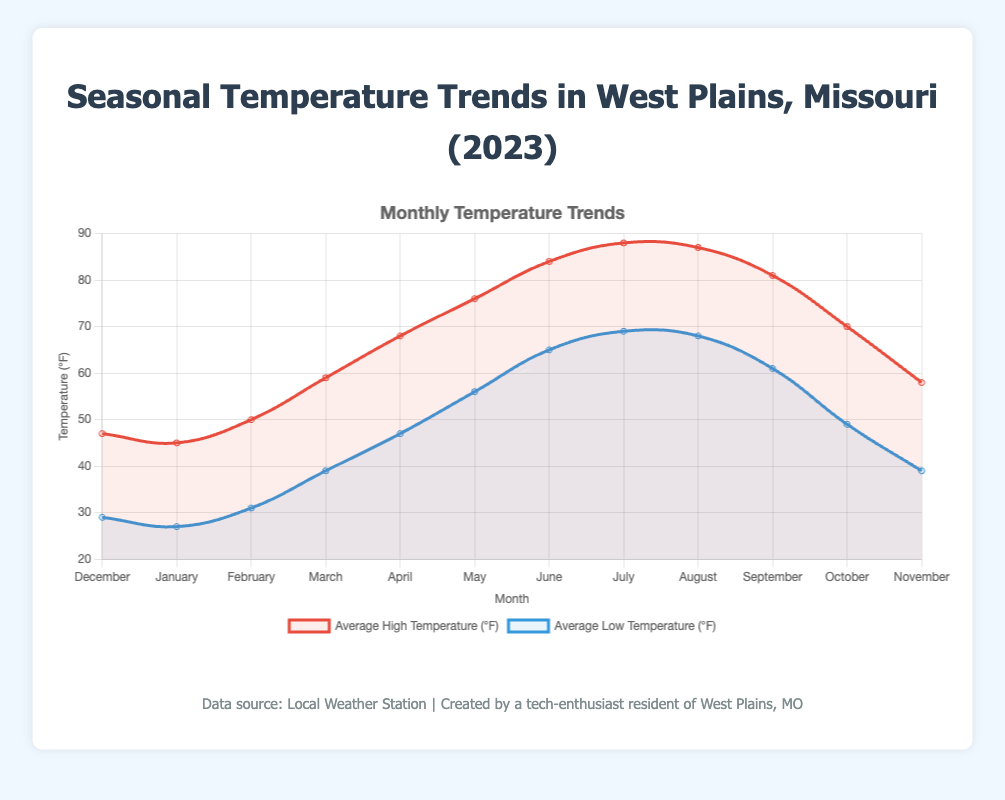When does West Plains, Missouri experience the highest average low temperature? The highest average low temperature can be identified by looking for the highest point on the blue line, which represents the average low temperatures. This occurs in July, with an average low temperature of 69°F.
Answer: July Which month has the greatest difference between the average high and low temperatures? To find this, calculate the difference between the high and low temperatures for each month and identify the largest difference. In May, the average high is 76°F, and the average low is 56°F, giving a difference of 20°F.
Answer: May Compare the average high temperatures in June and August. Is there a significant difference? The average high temperature in June is 84°F, while in August it is 87°F. The difference between the two is 3°F, which can be considered small.
Answer: No, the difference is small Which season shows the most consistent temperatures (smallest range between high and low)? To determine the most consistent season, calculate the temperature ranges (high minus low) for each season and compare them. Winter has differences of 18°F (47-29), 18°F (45-27), and 19°F (50-31), resulting in a consistent range around 18-19°F.
Answer: Winter What is the average high temperature for the spring months (March, April, May)? Add the average high temperatures for March (59°F), April (68°F), and May (76°F) and then divide by 3: (59 + 68 + 76)/3 = 67.67°F.
Answer: 67.67°F During which month is the average temperature closest to 70°F? To find this, consider both the high and low temperatures for each month and calculate the average of these two. For example, in October: (70 + 49) / 2 = 59.5°F, and in May: (76 + 56) / 2 = 66°F. The closest is in October with combined temperatures averaging near 70°F.
Answer: October How do the average high temperatures in September and January compare? September has an average high of 81°F, and January has an average high of 45°F. The difference can be calculated as 81 - 45 = 36°F, with September being significantly warmer.
Answer: September is significantly warmer What pattern can be observed in the high temperatures from March to May? The high temperatures display an increasing trend from March to May, rising from 59°F in March to 68°F in April, and reaching 76°F in May.
Answer: Increasing trend Which month has the lowest average low temperature and what is it? The lowest average low temperature can be observed by checking the points on the blue line representing each month’s low temperatures. January has the lowest average low temperature of 27°F.
Answer: January Is there a noticeable trend in the variation of average low temperatures throughout the year? By examining the blue line in the chart, one can see that average low temperatures generally rise from winter to summer, peaking in July, and then fall again towards winter.
Answer: Yes, rise and fall pattern 